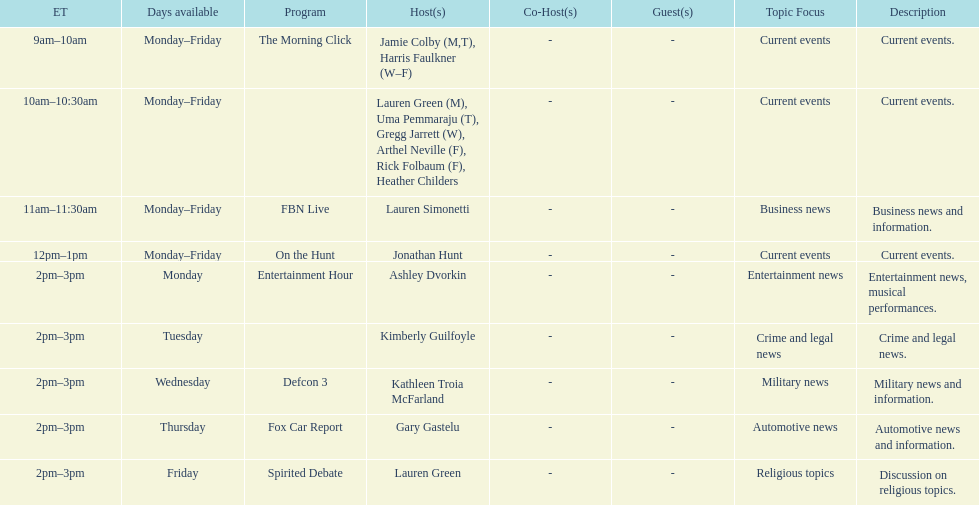What is the first show to play on monday mornings? The Morning Click. 